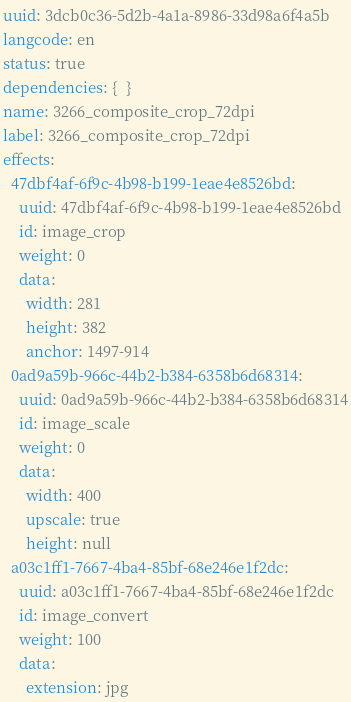Convert code to text. <code><loc_0><loc_0><loc_500><loc_500><_YAML_>uuid: 3dcb0c36-5d2b-4a1a-8986-33d98a6f4a5b
langcode: en
status: true
dependencies: {  }
name: 3266_composite_crop_72dpi
label: 3266_composite_crop_72dpi
effects:
  47dbf4af-6f9c-4b98-b199-1eae4e8526bd:
    uuid: 47dbf4af-6f9c-4b98-b199-1eae4e8526bd
    id: image_crop
    weight: 0
    data:
      width: 281
      height: 382
      anchor: 1497-914
  0ad9a59b-966c-44b2-b384-6358b6d68314:
    uuid: 0ad9a59b-966c-44b2-b384-6358b6d68314
    id: image_scale
    weight: 0
    data:
      width: 400
      upscale: true
      height: null
  a03c1ff1-7667-4ba4-85bf-68e246e1f2dc:
    uuid: a03c1ff1-7667-4ba4-85bf-68e246e1f2dc
    id: image_convert
    weight: 100
    data:
      extension: jpg
</code> 